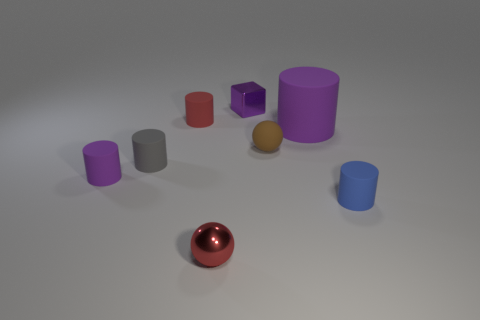What color is the shiny ball?
Ensure brevity in your answer.  Red. Is the shape of the brown rubber object the same as the small metal thing that is in front of the tiny purple cube?
Provide a succinct answer. Yes. How many other objects are the same material as the gray cylinder?
Provide a short and direct response. 5. What is the color of the metallic thing behind the sphere that is left of the tiny purple thing right of the red ball?
Your answer should be very brief. Purple. What shape is the small metallic object that is in front of the purple matte object that is right of the small gray cylinder?
Give a very brief answer. Sphere. Is the number of tiny red metal spheres on the right side of the tiny blue cylinder greater than the number of big rubber objects?
Your response must be concise. No. There is a purple object that is to the right of the brown rubber sphere; is its shape the same as the tiny red matte object?
Provide a succinct answer. Yes. Is there a purple shiny thing that has the same shape as the tiny blue thing?
Give a very brief answer. No. What number of things are cylinders that are to the left of the tiny brown object or large cyan matte objects?
Keep it short and to the point. 3. Are there more tiny blue matte cylinders than large gray balls?
Offer a terse response. Yes. 